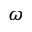<formula> <loc_0><loc_0><loc_500><loc_500>\omega</formula> 